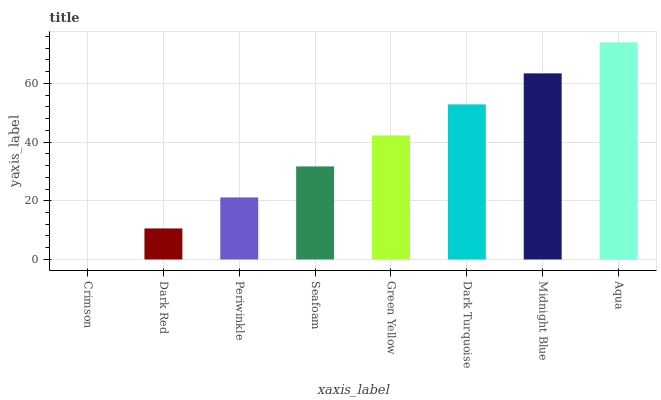Is Crimson the minimum?
Answer yes or no. Yes. Is Aqua the maximum?
Answer yes or no. Yes. Is Dark Red the minimum?
Answer yes or no. No. Is Dark Red the maximum?
Answer yes or no. No. Is Dark Red greater than Crimson?
Answer yes or no. Yes. Is Crimson less than Dark Red?
Answer yes or no. Yes. Is Crimson greater than Dark Red?
Answer yes or no. No. Is Dark Red less than Crimson?
Answer yes or no. No. Is Green Yellow the high median?
Answer yes or no. Yes. Is Seafoam the low median?
Answer yes or no. Yes. Is Seafoam the high median?
Answer yes or no. No. Is Midnight Blue the low median?
Answer yes or no. No. 